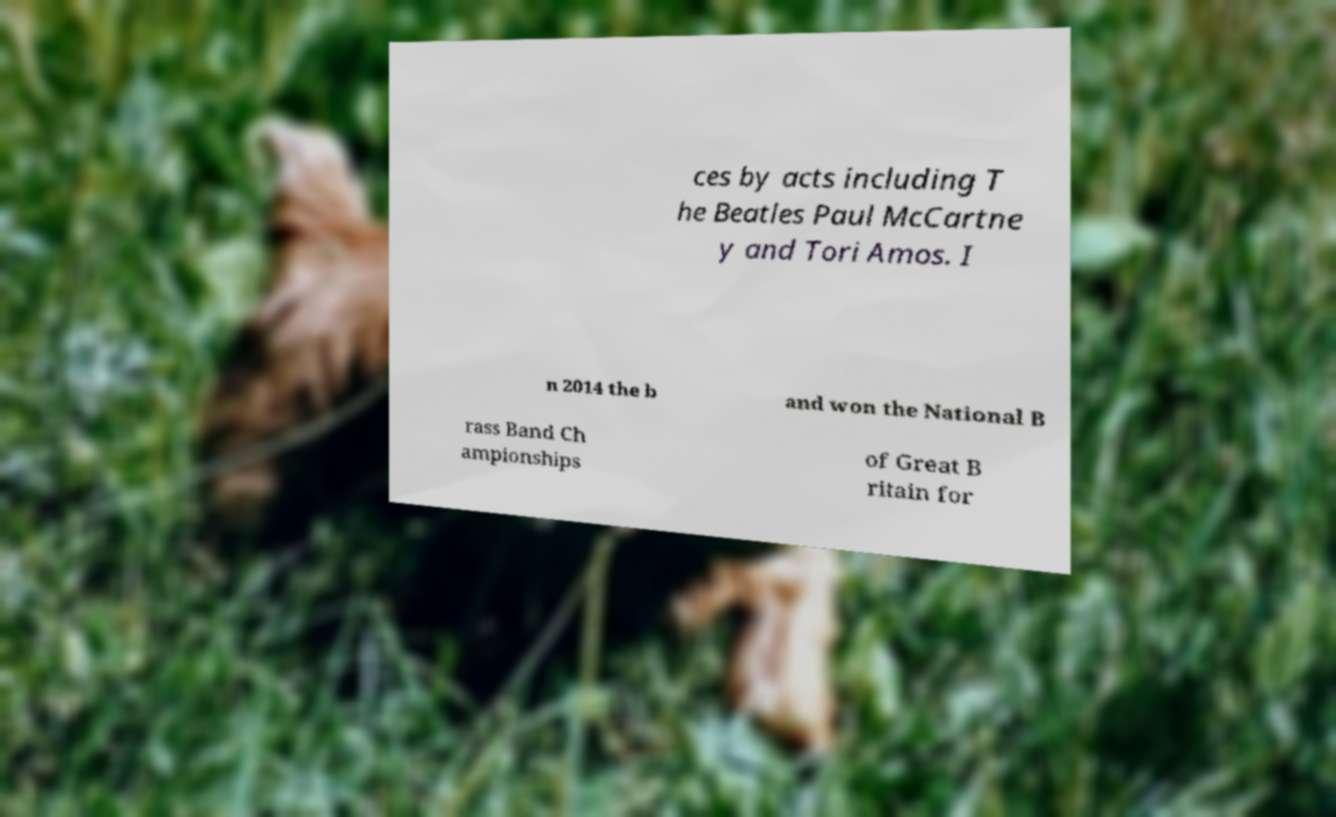What messages or text are displayed in this image? I need them in a readable, typed format. ces by acts including T he Beatles Paul McCartne y and Tori Amos. I n 2014 the b and won the National B rass Band Ch ampionships of Great B ritain for 